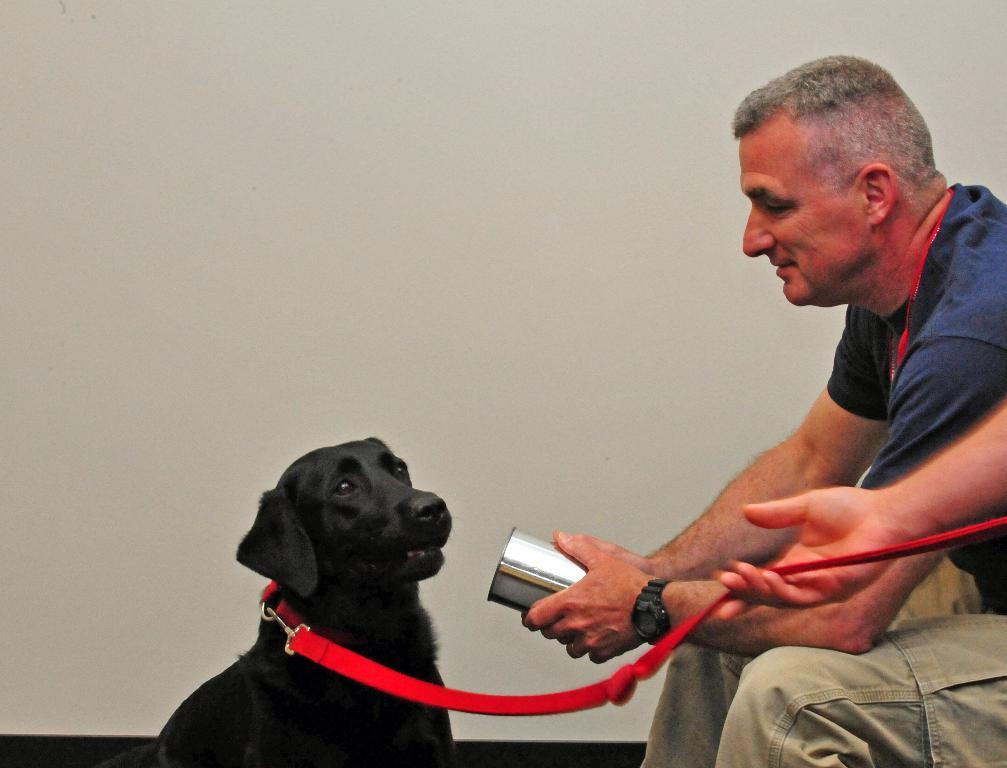What can be seen in the image? There is a person in the image, along with a black dog and a red color belt. What is the person holding in the image? The person is holding something, but the specific object cannot be determined from the provided facts. What color is the dog in the image? The dog in the image is black. What is the color of the color belt in the image? The color belt in the image is red. What is the background color of the image? The background of the image is white. What is the person's annual income in the image? There is no information about the person's income in the image. What type of station is depicted in the image? There is no station depicted in the image. Are there any police officers present in the image? There is no mention of police officers in the provided facts. 